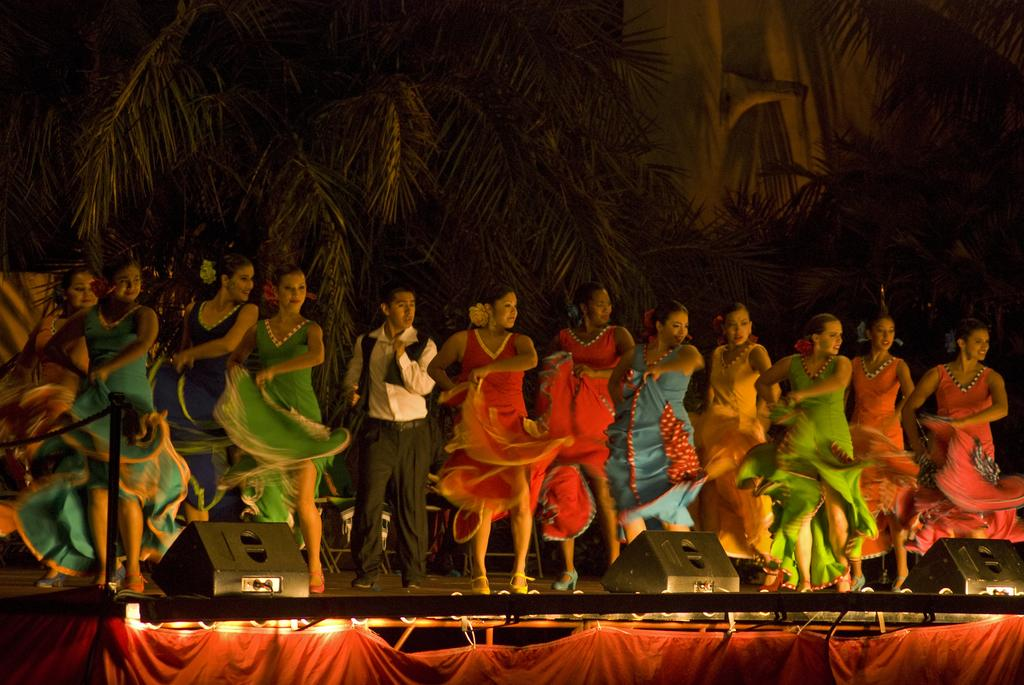What are the people in the image doing? The people in the image are dancing on the stage. What objects can be seen in the image besides the people? There are devices, a pole, lights, and a rope present in the image. What can be seen in the background of the image? There are trees and a wall visible in the background of the image. What type of hose is being used to water the trees in the image? There is no hose present in the image, and therefore no watering of trees is taking place. 